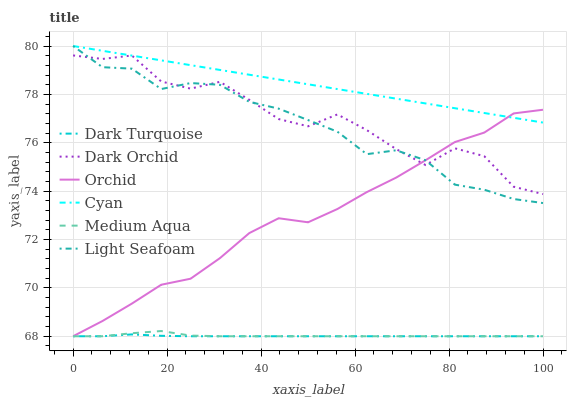Does Dark Turquoise have the minimum area under the curve?
Answer yes or no. Yes. Does Cyan have the maximum area under the curve?
Answer yes or no. Yes. Does Dark Orchid have the minimum area under the curve?
Answer yes or no. No. Does Dark Orchid have the maximum area under the curve?
Answer yes or no. No. Is Cyan the smoothest?
Answer yes or no. Yes. Is Dark Orchid the roughest?
Answer yes or no. Yes. Is Medium Aqua the smoothest?
Answer yes or no. No. Is Medium Aqua the roughest?
Answer yes or no. No. Does Dark Turquoise have the lowest value?
Answer yes or no. Yes. Does Dark Orchid have the lowest value?
Answer yes or no. No. Does Light Seafoam have the highest value?
Answer yes or no. Yes. Does Dark Orchid have the highest value?
Answer yes or no. No. Is Medium Aqua less than Cyan?
Answer yes or no. Yes. Is Dark Orchid greater than Medium Aqua?
Answer yes or no. Yes. Does Medium Aqua intersect Orchid?
Answer yes or no. Yes. Is Medium Aqua less than Orchid?
Answer yes or no. No. Is Medium Aqua greater than Orchid?
Answer yes or no. No. Does Medium Aqua intersect Cyan?
Answer yes or no. No. 